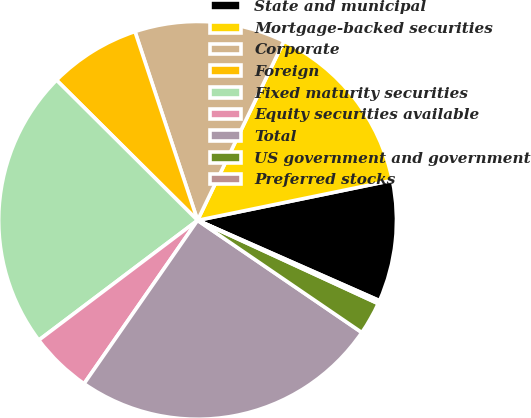Convert chart. <chart><loc_0><loc_0><loc_500><loc_500><pie_chart><fcel>State and municipal<fcel>Mortgage-backed securities<fcel>Corporate<fcel>Foreign<fcel>Fixed maturity securities<fcel>Equity securities available<fcel>Total<fcel>US government and government<fcel>Preferred stocks<nl><fcel>9.84%<fcel>14.63%<fcel>12.24%<fcel>7.45%<fcel>22.74%<fcel>5.05%<fcel>25.13%<fcel>2.66%<fcel>0.26%<nl></chart> 